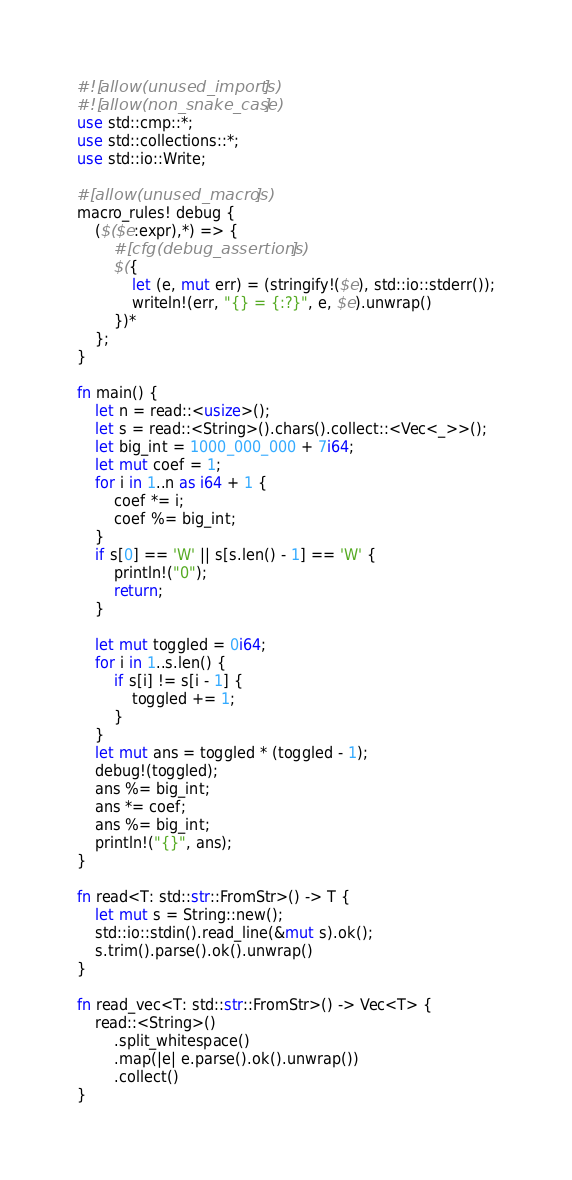Convert code to text. <code><loc_0><loc_0><loc_500><loc_500><_Rust_>#![allow(unused_imports)]
#![allow(non_snake_case)]
use std::cmp::*;
use std::collections::*;
use std::io::Write;

#[allow(unused_macros)]
macro_rules! debug {
    ($($e:expr),*) => {
        #[cfg(debug_assertions)]
        $({
            let (e, mut err) = (stringify!($e), std::io::stderr());
            writeln!(err, "{} = {:?}", e, $e).unwrap()
        })*
    };
}

fn main() {
    let n = read::<usize>();
    let s = read::<String>().chars().collect::<Vec<_>>();
    let big_int = 1000_000_000 + 7i64;
    let mut coef = 1;
    for i in 1..n as i64 + 1 {
        coef *= i;
        coef %= big_int;
    }
    if s[0] == 'W' || s[s.len() - 1] == 'W' {
        println!("0");
        return;
    }

    let mut toggled = 0i64;
    for i in 1..s.len() {
        if s[i] != s[i - 1] {
            toggled += 1;
        }
    }
    let mut ans = toggled * (toggled - 1);
    debug!(toggled);
    ans %= big_int;
    ans *= coef;
    ans %= big_int;
    println!("{}", ans);
}

fn read<T: std::str::FromStr>() -> T {
    let mut s = String::new();
    std::io::stdin().read_line(&mut s).ok();
    s.trim().parse().ok().unwrap()
}

fn read_vec<T: std::str::FromStr>() -> Vec<T> {
    read::<String>()
        .split_whitespace()
        .map(|e| e.parse().ok().unwrap())
        .collect()
}
</code> 